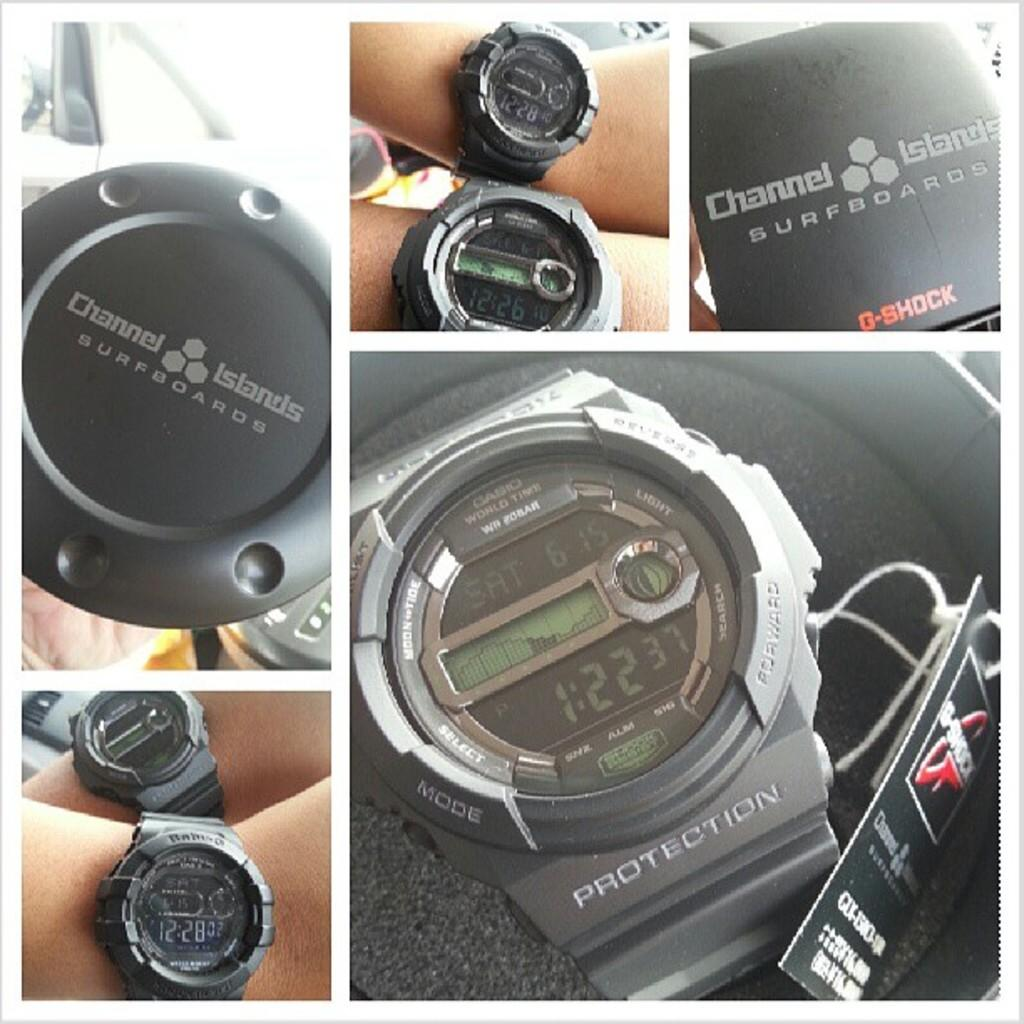<image>
Provide a brief description of the given image. A G Shock wrist watch from Channel Islands Surfboards. 